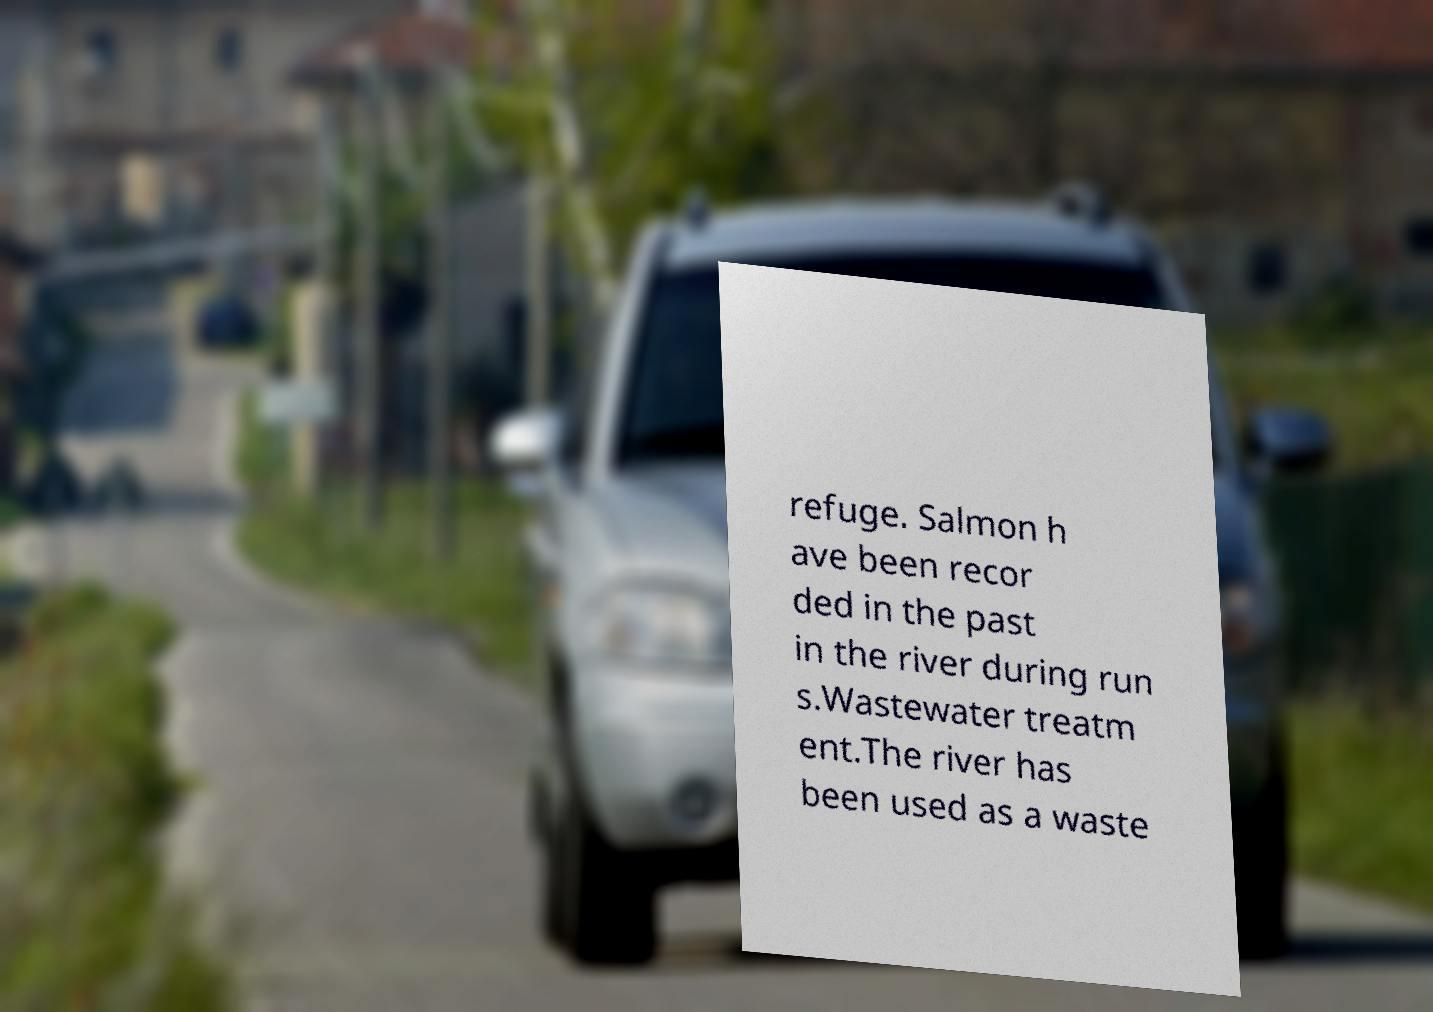Can you read and provide the text displayed in the image?This photo seems to have some interesting text. Can you extract and type it out for me? refuge. Salmon h ave been recor ded in the past in the river during run s.Wastewater treatm ent.The river has been used as a waste 